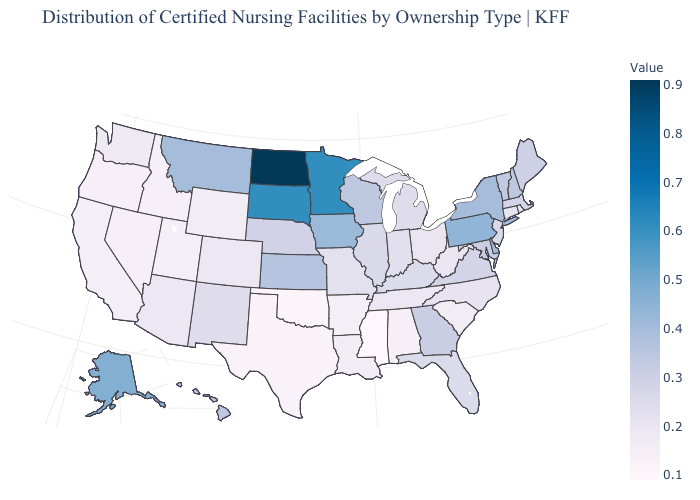Which states hav the highest value in the West?
Write a very short answer. Alaska. Does Delaware have the highest value in the South?
Answer briefly. Yes. Which states hav the highest value in the West?
Concise answer only. Alaska. Which states hav the highest value in the South?
Write a very short answer. Delaware. Which states have the lowest value in the Northeast?
Short answer required. Rhode Island. Does Kentucky have a lower value than Pennsylvania?
Concise answer only. Yes. Among the states that border Missouri , which have the lowest value?
Short answer required. Oklahoma. Which states have the lowest value in the South?
Keep it brief. Mississippi. 